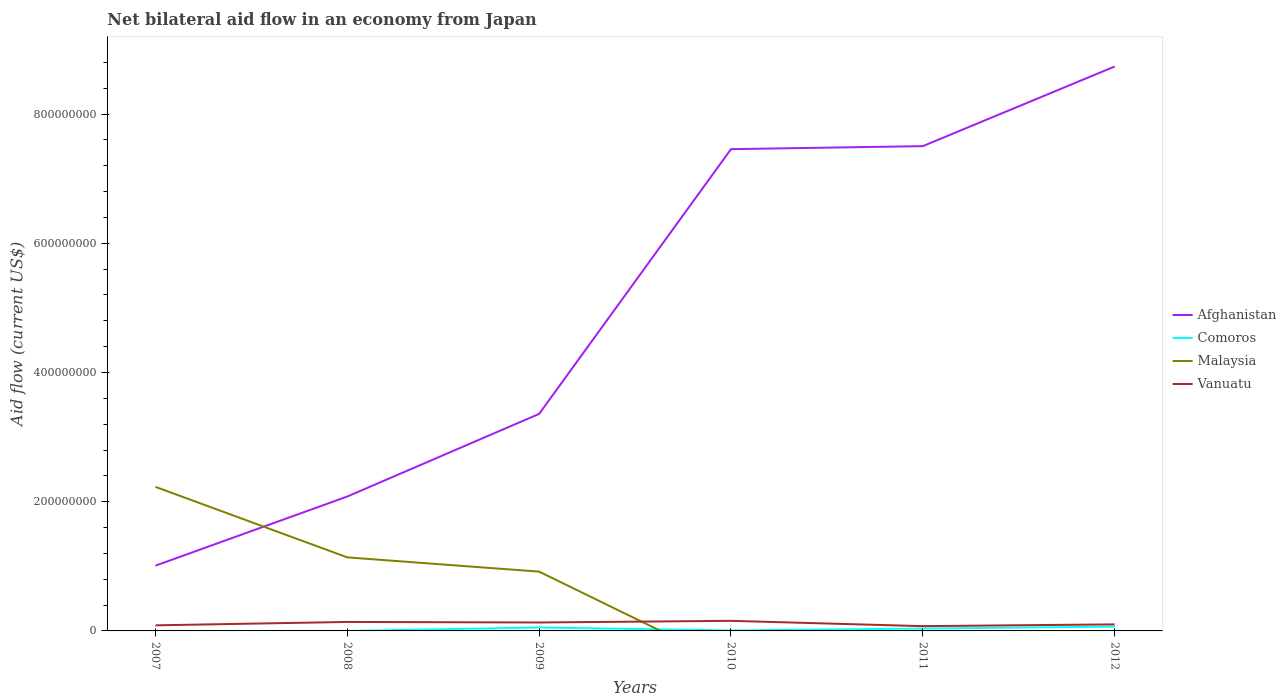What is the total net bilateral aid flow in Vanuatu in the graph?
Make the answer very short. -2.75e+06. What is the difference between the highest and the second highest net bilateral aid flow in Comoros?
Provide a succinct answer. 6.70e+06. Does the graph contain any zero values?
Your answer should be compact. Yes. How many legend labels are there?
Give a very brief answer. 4. How are the legend labels stacked?
Offer a very short reply. Vertical. What is the title of the graph?
Your answer should be very brief. Net bilateral aid flow in an economy from Japan. What is the label or title of the Y-axis?
Keep it short and to the point. Aid flow (current US$). What is the Aid flow (current US$) in Afghanistan in 2007?
Your response must be concise. 1.01e+08. What is the Aid flow (current US$) in Comoros in 2007?
Make the answer very short. 10000. What is the Aid flow (current US$) of Malaysia in 2007?
Offer a very short reply. 2.23e+08. What is the Aid flow (current US$) in Vanuatu in 2007?
Provide a succinct answer. 8.63e+06. What is the Aid flow (current US$) in Afghanistan in 2008?
Your answer should be very brief. 2.08e+08. What is the Aid flow (current US$) of Malaysia in 2008?
Offer a terse response. 1.14e+08. What is the Aid flow (current US$) in Vanuatu in 2008?
Keep it short and to the point. 1.39e+07. What is the Aid flow (current US$) in Afghanistan in 2009?
Your response must be concise. 3.36e+08. What is the Aid flow (current US$) in Comoros in 2009?
Give a very brief answer. 5.30e+06. What is the Aid flow (current US$) of Malaysia in 2009?
Keep it short and to the point. 9.18e+07. What is the Aid flow (current US$) in Vanuatu in 2009?
Make the answer very short. 1.31e+07. What is the Aid flow (current US$) in Afghanistan in 2010?
Your answer should be very brief. 7.46e+08. What is the Aid flow (current US$) of Comoros in 2010?
Offer a very short reply. 7.00e+05. What is the Aid flow (current US$) in Malaysia in 2010?
Offer a very short reply. 0. What is the Aid flow (current US$) in Vanuatu in 2010?
Ensure brevity in your answer.  1.56e+07. What is the Aid flow (current US$) of Afghanistan in 2011?
Provide a short and direct response. 7.50e+08. What is the Aid flow (current US$) in Comoros in 2011?
Offer a very short reply. 3.66e+06. What is the Aid flow (current US$) in Malaysia in 2011?
Make the answer very short. 0. What is the Aid flow (current US$) in Vanuatu in 2011?
Keep it short and to the point. 7.39e+06. What is the Aid flow (current US$) of Afghanistan in 2012?
Offer a terse response. 8.74e+08. What is the Aid flow (current US$) in Comoros in 2012?
Make the answer very short. 6.71e+06. What is the Aid flow (current US$) of Malaysia in 2012?
Offer a very short reply. 0. What is the Aid flow (current US$) of Vanuatu in 2012?
Provide a succinct answer. 1.01e+07. Across all years, what is the maximum Aid flow (current US$) in Afghanistan?
Your response must be concise. 8.74e+08. Across all years, what is the maximum Aid flow (current US$) in Comoros?
Offer a very short reply. 6.71e+06. Across all years, what is the maximum Aid flow (current US$) in Malaysia?
Provide a short and direct response. 2.23e+08. Across all years, what is the maximum Aid flow (current US$) of Vanuatu?
Ensure brevity in your answer.  1.56e+07. Across all years, what is the minimum Aid flow (current US$) in Afghanistan?
Ensure brevity in your answer.  1.01e+08. Across all years, what is the minimum Aid flow (current US$) in Malaysia?
Your answer should be compact. 0. Across all years, what is the minimum Aid flow (current US$) in Vanuatu?
Your answer should be very brief. 7.39e+06. What is the total Aid flow (current US$) in Afghanistan in the graph?
Provide a short and direct response. 3.01e+09. What is the total Aid flow (current US$) in Comoros in the graph?
Make the answer very short. 1.64e+07. What is the total Aid flow (current US$) in Malaysia in the graph?
Keep it short and to the point. 4.29e+08. What is the total Aid flow (current US$) in Vanuatu in the graph?
Offer a very short reply. 6.88e+07. What is the difference between the Aid flow (current US$) in Afghanistan in 2007 and that in 2008?
Provide a short and direct response. -1.07e+08. What is the difference between the Aid flow (current US$) in Comoros in 2007 and that in 2008?
Your response must be concise. -2.00e+04. What is the difference between the Aid flow (current US$) of Malaysia in 2007 and that in 2008?
Your answer should be very brief. 1.09e+08. What is the difference between the Aid flow (current US$) of Vanuatu in 2007 and that in 2008?
Offer a terse response. -5.28e+06. What is the difference between the Aid flow (current US$) of Afghanistan in 2007 and that in 2009?
Your response must be concise. -2.35e+08. What is the difference between the Aid flow (current US$) of Comoros in 2007 and that in 2009?
Your answer should be very brief. -5.29e+06. What is the difference between the Aid flow (current US$) of Malaysia in 2007 and that in 2009?
Ensure brevity in your answer.  1.31e+08. What is the difference between the Aid flow (current US$) of Vanuatu in 2007 and that in 2009?
Offer a very short reply. -4.44e+06. What is the difference between the Aid flow (current US$) of Afghanistan in 2007 and that in 2010?
Your response must be concise. -6.45e+08. What is the difference between the Aid flow (current US$) in Comoros in 2007 and that in 2010?
Offer a very short reply. -6.90e+05. What is the difference between the Aid flow (current US$) of Vanuatu in 2007 and that in 2010?
Provide a succinct answer. -6.98e+06. What is the difference between the Aid flow (current US$) in Afghanistan in 2007 and that in 2011?
Make the answer very short. -6.49e+08. What is the difference between the Aid flow (current US$) of Comoros in 2007 and that in 2011?
Ensure brevity in your answer.  -3.65e+06. What is the difference between the Aid flow (current US$) in Vanuatu in 2007 and that in 2011?
Your answer should be very brief. 1.24e+06. What is the difference between the Aid flow (current US$) in Afghanistan in 2007 and that in 2012?
Offer a very short reply. -7.73e+08. What is the difference between the Aid flow (current US$) of Comoros in 2007 and that in 2012?
Your answer should be very brief. -6.70e+06. What is the difference between the Aid flow (current US$) in Vanuatu in 2007 and that in 2012?
Provide a short and direct response. -1.51e+06. What is the difference between the Aid flow (current US$) of Afghanistan in 2008 and that in 2009?
Your answer should be very brief. -1.28e+08. What is the difference between the Aid flow (current US$) in Comoros in 2008 and that in 2009?
Your answer should be very brief. -5.27e+06. What is the difference between the Aid flow (current US$) of Malaysia in 2008 and that in 2009?
Your answer should be very brief. 2.20e+07. What is the difference between the Aid flow (current US$) of Vanuatu in 2008 and that in 2009?
Your response must be concise. 8.40e+05. What is the difference between the Aid flow (current US$) of Afghanistan in 2008 and that in 2010?
Offer a terse response. -5.38e+08. What is the difference between the Aid flow (current US$) in Comoros in 2008 and that in 2010?
Your response must be concise. -6.70e+05. What is the difference between the Aid flow (current US$) in Vanuatu in 2008 and that in 2010?
Provide a succinct answer. -1.70e+06. What is the difference between the Aid flow (current US$) of Afghanistan in 2008 and that in 2011?
Your response must be concise. -5.42e+08. What is the difference between the Aid flow (current US$) in Comoros in 2008 and that in 2011?
Your answer should be compact. -3.63e+06. What is the difference between the Aid flow (current US$) in Vanuatu in 2008 and that in 2011?
Offer a terse response. 6.52e+06. What is the difference between the Aid flow (current US$) in Afghanistan in 2008 and that in 2012?
Give a very brief answer. -6.66e+08. What is the difference between the Aid flow (current US$) in Comoros in 2008 and that in 2012?
Make the answer very short. -6.68e+06. What is the difference between the Aid flow (current US$) of Vanuatu in 2008 and that in 2012?
Keep it short and to the point. 3.77e+06. What is the difference between the Aid flow (current US$) of Afghanistan in 2009 and that in 2010?
Your response must be concise. -4.10e+08. What is the difference between the Aid flow (current US$) in Comoros in 2009 and that in 2010?
Ensure brevity in your answer.  4.60e+06. What is the difference between the Aid flow (current US$) in Vanuatu in 2009 and that in 2010?
Your answer should be compact. -2.54e+06. What is the difference between the Aid flow (current US$) in Afghanistan in 2009 and that in 2011?
Give a very brief answer. -4.14e+08. What is the difference between the Aid flow (current US$) of Comoros in 2009 and that in 2011?
Keep it short and to the point. 1.64e+06. What is the difference between the Aid flow (current US$) of Vanuatu in 2009 and that in 2011?
Provide a short and direct response. 5.68e+06. What is the difference between the Aid flow (current US$) in Afghanistan in 2009 and that in 2012?
Offer a terse response. -5.38e+08. What is the difference between the Aid flow (current US$) of Comoros in 2009 and that in 2012?
Your answer should be compact. -1.41e+06. What is the difference between the Aid flow (current US$) in Vanuatu in 2009 and that in 2012?
Make the answer very short. 2.93e+06. What is the difference between the Aid flow (current US$) in Afghanistan in 2010 and that in 2011?
Your answer should be compact. -4.68e+06. What is the difference between the Aid flow (current US$) in Comoros in 2010 and that in 2011?
Make the answer very short. -2.96e+06. What is the difference between the Aid flow (current US$) in Vanuatu in 2010 and that in 2011?
Offer a terse response. 8.22e+06. What is the difference between the Aid flow (current US$) of Afghanistan in 2010 and that in 2012?
Give a very brief answer. -1.28e+08. What is the difference between the Aid flow (current US$) of Comoros in 2010 and that in 2012?
Make the answer very short. -6.01e+06. What is the difference between the Aid flow (current US$) in Vanuatu in 2010 and that in 2012?
Ensure brevity in your answer.  5.47e+06. What is the difference between the Aid flow (current US$) in Afghanistan in 2011 and that in 2012?
Ensure brevity in your answer.  -1.23e+08. What is the difference between the Aid flow (current US$) in Comoros in 2011 and that in 2012?
Make the answer very short. -3.05e+06. What is the difference between the Aid flow (current US$) of Vanuatu in 2011 and that in 2012?
Your answer should be compact. -2.75e+06. What is the difference between the Aid flow (current US$) of Afghanistan in 2007 and the Aid flow (current US$) of Comoros in 2008?
Ensure brevity in your answer.  1.01e+08. What is the difference between the Aid flow (current US$) of Afghanistan in 2007 and the Aid flow (current US$) of Malaysia in 2008?
Your answer should be compact. -1.28e+07. What is the difference between the Aid flow (current US$) in Afghanistan in 2007 and the Aid flow (current US$) in Vanuatu in 2008?
Ensure brevity in your answer.  8.71e+07. What is the difference between the Aid flow (current US$) in Comoros in 2007 and the Aid flow (current US$) in Malaysia in 2008?
Give a very brief answer. -1.14e+08. What is the difference between the Aid flow (current US$) in Comoros in 2007 and the Aid flow (current US$) in Vanuatu in 2008?
Your answer should be compact. -1.39e+07. What is the difference between the Aid flow (current US$) in Malaysia in 2007 and the Aid flow (current US$) in Vanuatu in 2008?
Your answer should be very brief. 2.09e+08. What is the difference between the Aid flow (current US$) in Afghanistan in 2007 and the Aid flow (current US$) in Comoros in 2009?
Ensure brevity in your answer.  9.57e+07. What is the difference between the Aid flow (current US$) in Afghanistan in 2007 and the Aid flow (current US$) in Malaysia in 2009?
Your response must be concise. 9.23e+06. What is the difference between the Aid flow (current US$) in Afghanistan in 2007 and the Aid flow (current US$) in Vanuatu in 2009?
Offer a terse response. 8.79e+07. What is the difference between the Aid flow (current US$) of Comoros in 2007 and the Aid flow (current US$) of Malaysia in 2009?
Offer a terse response. -9.18e+07. What is the difference between the Aid flow (current US$) in Comoros in 2007 and the Aid flow (current US$) in Vanuatu in 2009?
Make the answer very short. -1.31e+07. What is the difference between the Aid flow (current US$) of Malaysia in 2007 and the Aid flow (current US$) of Vanuatu in 2009?
Your response must be concise. 2.10e+08. What is the difference between the Aid flow (current US$) of Afghanistan in 2007 and the Aid flow (current US$) of Comoros in 2010?
Offer a very short reply. 1.00e+08. What is the difference between the Aid flow (current US$) in Afghanistan in 2007 and the Aid flow (current US$) in Vanuatu in 2010?
Your response must be concise. 8.54e+07. What is the difference between the Aid flow (current US$) in Comoros in 2007 and the Aid flow (current US$) in Vanuatu in 2010?
Your answer should be very brief. -1.56e+07. What is the difference between the Aid flow (current US$) of Malaysia in 2007 and the Aid flow (current US$) of Vanuatu in 2010?
Provide a succinct answer. 2.07e+08. What is the difference between the Aid flow (current US$) in Afghanistan in 2007 and the Aid flow (current US$) in Comoros in 2011?
Your answer should be compact. 9.74e+07. What is the difference between the Aid flow (current US$) in Afghanistan in 2007 and the Aid flow (current US$) in Vanuatu in 2011?
Offer a terse response. 9.36e+07. What is the difference between the Aid flow (current US$) of Comoros in 2007 and the Aid flow (current US$) of Vanuatu in 2011?
Ensure brevity in your answer.  -7.38e+06. What is the difference between the Aid flow (current US$) in Malaysia in 2007 and the Aid flow (current US$) in Vanuatu in 2011?
Your response must be concise. 2.16e+08. What is the difference between the Aid flow (current US$) in Afghanistan in 2007 and the Aid flow (current US$) in Comoros in 2012?
Offer a very short reply. 9.43e+07. What is the difference between the Aid flow (current US$) of Afghanistan in 2007 and the Aid flow (current US$) of Vanuatu in 2012?
Give a very brief answer. 9.09e+07. What is the difference between the Aid flow (current US$) of Comoros in 2007 and the Aid flow (current US$) of Vanuatu in 2012?
Provide a short and direct response. -1.01e+07. What is the difference between the Aid flow (current US$) of Malaysia in 2007 and the Aid flow (current US$) of Vanuatu in 2012?
Ensure brevity in your answer.  2.13e+08. What is the difference between the Aid flow (current US$) of Afghanistan in 2008 and the Aid flow (current US$) of Comoros in 2009?
Offer a terse response. 2.03e+08. What is the difference between the Aid flow (current US$) in Afghanistan in 2008 and the Aid flow (current US$) in Malaysia in 2009?
Your answer should be very brief. 1.16e+08. What is the difference between the Aid flow (current US$) in Afghanistan in 2008 and the Aid flow (current US$) in Vanuatu in 2009?
Offer a terse response. 1.95e+08. What is the difference between the Aid flow (current US$) of Comoros in 2008 and the Aid flow (current US$) of Malaysia in 2009?
Provide a succinct answer. -9.18e+07. What is the difference between the Aid flow (current US$) of Comoros in 2008 and the Aid flow (current US$) of Vanuatu in 2009?
Provide a short and direct response. -1.30e+07. What is the difference between the Aid flow (current US$) of Malaysia in 2008 and the Aid flow (current US$) of Vanuatu in 2009?
Provide a short and direct response. 1.01e+08. What is the difference between the Aid flow (current US$) of Afghanistan in 2008 and the Aid flow (current US$) of Comoros in 2010?
Ensure brevity in your answer.  2.07e+08. What is the difference between the Aid flow (current US$) of Afghanistan in 2008 and the Aid flow (current US$) of Vanuatu in 2010?
Your answer should be compact. 1.92e+08. What is the difference between the Aid flow (current US$) of Comoros in 2008 and the Aid flow (current US$) of Vanuatu in 2010?
Ensure brevity in your answer.  -1.56e+07. What is the difference between the Aid flow (current US$) of Malaysia in 2008 and the Aid flow (current US$) of Vanuatu in 2010?
Your answer should be very brief. 9.82e+07. What is the difference between the Aid flow (current US$) in Afghanistan in 2008 and the Aid flow (current US$) in Comoros in 2011?
Give a very brief answer. 2.04e+08. What is the difference between the Aid flow (current US$) of Afghanistan in 2008 and the Aid flow (current US$) of Vanuatu in 2011?
Your answer should be compact. 2.01e+08. What is the difference between the Aid flow (current US$) of Comoros in 2008 and the Aid flow (current US$) of Vanuatu in 2011?
Make the answer very short. -7.36e+06. What is the difference between the Aid flow (current US$) of Malaysia in 2008 and the Aid flow (current US$) of Vanuatu in 2011?
Your answer should be compact. 1.06e+08. What is the difference between the Aid flow (current US$) of Afghanistan in 2008 and the Aid flow (current US$) of Comoros in 2012?
Make the answer very short. 2.01e+08. What is the difference between the Aid flow (current US$) of Afghanistan in 2008 and the Aid flow (current US$) of Vanuatu in 2012?
Provide a short and direct response. 1.98e+08. What is the difference between the Aid flow (current US$) in Comoros in 2008 and the Aid flow (current US$) in Vanuatu in 2012?
Give a very brief answer. -1.01e+07. What is the difference between the Aid flow (current US$) in Malaysia in 2008 and the Aid flow (current US$) in Vanuatu in 2012?
Ensure brevity in your answer.  1.04e+08. What is the difference between the Aid flow (current US$) of Afghanistan in 2009 and the Aid flow (current US$) of Comoros in 2010?
Your answer should be very brief. 3.35e+08. What is the difference between the Aid flow (current US$) of Afghanistan in 2009 and the Aid flow (current US$) of Vanuatu in 2010?
Your answer should be compact. 3.20e+08. What is the difference between the Aid flow (current US$) in Comoros in 2009 and the Aid flow (current US$) in Vanuatu in 2010?
Make the answer very short. -1.03e+07. What is the difference between the Aid flow (current US$) in Malaysia in 2009 and the Aid flow (current US$) in Vanuatu in 2010?
Keep it short and to the point. 7.62e+07. What is the difference between the Aid flow (current US$) of Afghanistan in 2009 and the Aid flow (current US$) of Comoros in 2011?
Offer a terse response. 3.32e+08. What is the difference between the Aid flow (current US$) of Afghanistan in 2009 and the Aid flow (current US$) of Vanuatu in 2011?
Ensure brevity in your answer.  3.29e+08. What is the difference between the Aid flow (current US$) of Comoros in 2009 and the Aid flow (current US$) of Vanuatu in 2011?
Offer a very short reply. -2.09e+06. What is the difference between the Aid flow (current US$) in Malaysia in 2009 and the Aid flow (current US$) in Vanuatu in 2011?
Offer a very short reply. 8.44e+07. What is the difference between the Aid flow (current US$) of Afghanistan in 2009 and the Aid flow (current US$) of Comoros in 2012?
Your response must be concise. 3.29e+08. What is the difference between the Aid flow (current US$) in Afghanistan in 2009 and the Aid flow (current US$) in Vanuatu in 2012?
Provide a short and direct response. 3.26e+08. What is the difference between the Aid flow (current US$) of Comoros in 2009 and the Aid flow (current US$) of Vanuatu in 2012?
Your answer should be compact. -4.84e+06. What is the difference between the Aid flow (current US$) of Malaysia in 2009 and the Aid flow (current US$) of Vanuatu in 2012?
Ensure brevity in your answer.  8.16e+07. What is the difference between the Aid flow (current US$) of Afghanistan in 2010 and the Aid flow (current US$) of Comoros in 2011?
Your answer should be very brief. 7.42e+08. What is the difference between the Aid flow (current US$) in Afghanistan in 2010 and the Aid flow (current US$) in Vanuatu in 2011?
Offer a terse response. 7.38e+08. What is the difference between the Aid flow (current US$) of Comoros in 2010 and the Aid flow (current US$) of Vanuatu in 2011?
Your response must be concise. -6.69e+06. What is the difference between the Aid flow (current US$) in Afghanistan in 2010 and the Aid flow (current US$) in Comoros in 2012?
Offer a terse response. 7.39e+08. What is the difference between the Aid flow (current US$) in Afghanistan in 2010 and the Aid flow (current US$) in Vanuatu in 2012?
Your answer should be compact. 7.36e+08. What is the difference between the Aid flow (current US$) of Comoros in 2010 and the Aid flow (current US$) of Vanuatu in 2012?
Provide a succinct answer. -9.44e+06. What is the difference between the Aid flow (current US$) of Afghanistan in 2011 and the Aid flow (current US$) of Comoros in 2012?
Keep it short and to the point. 7.44e+08. What is the difference between the Aid flow (current US$) of Afghanistan in 2011 and the Aid flow (current US$) of Vanuatu in 2012?
Offer a very short reply. 7.40e+08. What is the difference between the Aid flow (current US$) in Comoros in 2011 and the Aid flow (current US$) in Vanuatu in 2012?
Your answer should be compact. -6.48e+06. What is the average Aid flow (current US$) in Afghanistan per year?
Offer a terse response. 5.02e+08. What is the average Aid flow (current US$) in Comoros per year?
Your response must be concise. 2.74e+06. What is the average Aid flow (current US$) in Malaysia per year?
Give a very brief answer. 7.14e+07. What is the average Aid flow (current US$) of Vanuatu per year?
Offer a very short reply. 1.15e+07. In the year 2007, what is the difference between the Aid flow (current US$) in Afghanistan and Aid flow (current US$) in Comoros?
Keep it short and to the point. 1.01e+08. In the year 2007, what is the difference between the Aid flow (current US$) in Afghanistan and Aid flow (current US$) in Malaysia?
Offer a very short reply. -1.22e+08. In the year 2007, what is the difference between the Aid flow (current US$) in Afghanistan and Aid flow (current US$) in Vanuatu?
Give a very brief answer. 9.24e+07. In the year 2007, what is the difference between the Aid flow (current US$) in Comoros and Aid flow (current US$) in Malaysia?
Your answer should be compact. -2.23e+08. In the year 2007, what is the difference between the Aid flow (current US$) of Comoros and Aid flow (current US$) of Vanuatu?
Offer a very short reply. -8.62e+06. In the year 2007, what is the difference between the Aid flow (current US$) in Malaysia and Aid flow (current US$) in Vanuatu?
Offer a terse response. 2.14e+08. In the year 2008, what is the difference between the Aid flow (current US$) of Afghanistan and Aid flow (current US$) of Comoros?
Your answer should be compact. 2.08e+08. In the year 2008, what is the difference between the Aid flow (current US$) in Afghanistan and Aid flow (current US$) in Malaysia?
Ensure brevity in your answer.  9.42e+07. In the year 2008, what is the difference between the Aid flow (current US$) in Afghanistan and Aid flow (current US$) in Vanuatu?
Give a very brief answer. 1.94e+08. In the year 2008, what is the difference between the Aid flow (current US$) in Comoros and Aid flow (current US$) in Malaysia?
Your answer should be very brief. -1.14e+08. In the year 2008, what is the difference between the Aid flow (current US$) in Comoros and Aid flow (current US$) in Vanuatu?
Your response must be concise. -1.39e+07. In the year 2008, what is the difference between the Aid flow (current US$) of Malaysia and Aid flow (current US$) of Vanuatu?
Your answer should be compact. 9.99e+07. In the year 2009, what is the difference between the Aid flow (current US$) in Afghanistan and Aid flow (current US$) in Comoros?
Offer a very short reply. 3.31e+08. In the year 2009, what is the difference between the Aid flow (current US$) of Afghanistan and Aid flow (current US$) of Malaysia?
Your response must be concise. 2.44e+08. In the year 2009, what is the difference between the Aid flow (current US$) of Afghanistan and Aid flow (current US$) of Vanuatu?
Offer a very short reply. 3.23e+08. In the year 2009, what is the difference between the Aid flow (current US$) in Comoros and Aid flow (current US$) in Malaysia?
Make the answer very short. -8.65e+07. In the year 2009, what is the difference between the Aid flow (current US$) in Comoros and Aid flow (current US$) in Vanuatu?
Keep it short and to the point. -7.77e+06. In the year 2009, what is the difference between the Aid flow (current US$) of Malaysia and Aid flow (current US$) of Vanuatu?
Offer a terse response. 7.87e+07. In the year 2010, what is the difference between the Aid flow (current US$) in Afghanistan and Aid flow (current US$) in Comoros?
Ensure brevity in your answer.  7.45e+08. In the year 2010, what is the difference between the Aid flow (current US$) of Afghanistan and Aid flow (current US$) of Vanuatu?
Keep it short and to the point. 7.30e+08. In the year 2010, what is the difference between the Aid flow (current US$) of Comoros and Aid flow (current US$) of Vanuatu?
Ensure brevity in your answer.  -1.49e+07. In the year 2011, what is the difference between the Aid flow (current US$) of Afghanistan and Aid flow (current US$) of Comoros?
Make the answer very short. 7.47e+08. In the year 2011, what is the difference between the Aid flow (current US$) in Afghanistan and Aid flow (current US$) in Vanuatu?
Offer a very short reply. 7.43e+08. In the year 2011, what is the difference between the Aid flow (current US$) of Comoros and Aid flow (current US$) of Vanuatu?
Make the answer very short. -3.73e+06. In the year 2012, what is the difference between the Aid flow (current US$) in Afghanistan and Aid flow (current US$) in Comoros?
Your answer should be compact. 8.67e+08. In the year 2012, what is the difference between the Aid flow (current US$) in Afghanistan and Aid flow (current US$) in Vanuatu?
Your answer should be compact. 8.63e+08. In the year 2012, what is the difference between the Aid flow (current US$) in Comoros and Aid flow (current US$) in Vanuatu?
Make the answer very short. -3.43e+06. What is the ratio of the Aid flow (current US$) in Afghanistan in 2007 to that in 2008?
Offer a very short reply. 0.49. What is the ratio of the Aid flow (current US$) in Malaysia in 2007 to that in 2008?
Provide a short and direct response. 1.96. What is the ratio of the Aid flow (current US$) in Vanuatu in 2007 to that in 2008?
Keep it short and to the point. 0.62. What is the ratio of the Aid flow (current US$) of Afghanistan in 2007 to that in 2009?
Offer a very short reply. 0.3. What is the ratio of the Aid flow (current US$) in Comoros in 2007 to that in 2009?
Your answer should be very brief. 0. What is the ratio of the Aid flow (current US$) in Malaysia in 2007 to that in 2009?
Your response must be concise. 2.43. What is the ratio of the Aid flow (current US$) of Vanuatu in 2007 to that in 2009?
Your response must be concise. 0.66. What is the ratio of the Aid flow (current US$) of Afghanistan in 2007 to that in 2010?
Provide a short and direct response. 0.14. What is the ratio of the Aid flow (current US$) of Comoros in 2007 to that in 2010?
Provide a short and direct response. 0.01. What is the ratio of the Aid flow (current US$) in Vanuatu in 2007 to that in 2010?
Offer a terse response. 0.55. What is the ratio of the Aid flow (current US$) in Afghanistan in 2007 to that in 2011?
Offer a very short reply. 0.13. What is the ratio of the Aid flow (current US$) of Comoros in 2007 to that in 2011?
Ensure brevity in your answer.  0. What is the ratio of the Aid flow (current US$) in Vanuatu in 2007 to that in 2011?
Give a very brief answer. 1.17. What is the ratio of the Aid flow (current US$) of Afghanistan in 2007 to that in 2012?
Provide a short and direct response. 0.12. What is the ratio of the Aid flow (current US$) in Comoros in 2007 to that in 2012?
Your answer should be compact. 0. What is the ratio of the Aid flow (current US$) in Vanuatu in 2007 to that in 2012?
Offer a very short reply. 0.85. What is the ratio of the Aid flow (current US$) in Afghanistan in 2008 to that in 2009?
Your answer should be compact. 0.62. What is the ratio of the Aid flow (current US$) of Comoros in 2008 to that in 2009?
Your answer should be compact. 0.01. What is the ratio of the Aid flow (current US$) of Malaysia in 2008 to that in 2009?
Your answer should be very brief. 1.24. What is the ratio of the Aid flow (current US$) of Vanuatu in 2008 to that in 2009?
Ensure brevity in your answer.  1.06. What is the ratio of the Aid flow (current US$) in Afghanistan in 2008 to that in 2010?
Provide a short and direct response. 0.28. What is the ratio of the Aid flow (current US$) of Comoros in 2008 to that in 2010?
Your answer should be very brief. 0.04. What is the ratio of the Aid flow (current US$) of Vanuatu in 2008 to that in 2010?
Offer a terse response. 0.89. What is the ratio of the Aid flow (current US$) in Afghanistan in 2008 to that in 2011?
Your answer should be compact. 0.28. What is the ratio of the Aid flow (current US$) of Comoros in 2008 to that in 2011?
Provide a succinct answer. 0.01. What is the ratio of the Aid flow (current US$) of Vanuatu in 2008 to that in 2011?
Make the answer very short. 1.88. What is the ratio of the Aid flow (current US$) of Afghanistan in 2008 to that in 2012?
Give a very brief answer. 0.24. What is the ratio of the Aid flow (current US$) in Comoros in 2008 to that in 2012?
Provide a succinct answer. 0. What is the ratio of the Aid flow (current US$) in Vanuatu in 2008 to that in 2012?
Offer a very short reply. 1.37. What is the ratio of the Aid flow (current US$) of Afghanistan in 2009 to that in 2010?
Your answer should be compact. 0.45. What is the ratio of the Aid flow (current US$) in Comoros in 2009 to that in 2010?
Offer a terse response. 7.57. What is the ratio of the Aid flow (current US$) of Vanuatu in 2009 to that in 2010?
Provide a short and direct response. 0.84. What is the ratio of the Aid flow (current US$) in Afghanistan in 2009 to that in 2011?
Your answer should be compact. 0.45. What is the ratio of the Aid flow (current US$) in Comoros in 2009 to that in 2011?
Give a very brief answer. 1.45. What is the ratio of the Aid flow (current US$) of Vanuatu in 2009 to that in 2011?
Offer a terse response. 1.77. What is the ratio of the Aid flow (current US$) in Afghanistan in 2009 to that in 2012?
Offer a very short reply. 0.38. What is the ratio of the Aid flow (current US$) in Comoros in 2009 to that in 2012?
Keep it short and to the point. 0.79. What is the ratio of the Aid flow (current US$) of Vanuatu in 2009 to that in 2012?
Your answer should be very brief. 1.29. What is the ratio of the Aid flow (current US$) of Comoros in 2010 to that in 2011?
Your response must be concise. 0.19. What is the ratio of the Aid flow (current US$) in Vanuatu in 2010 to that in 2011?
Give a very brief answer. 2.11. What is the ratio of the Aid flow (current US$) in Afghanistan in 2010 to that in 2012?
Your response must be concise. 0.85. What is the ratio of the Aid flow (current US$) of Comoros in 2010 to that in 2012?
Your answer should be compact. 0.1. What is the ratio of the Aid flow (current US$) of Vanuatu in 2010 to that in 2012?
Your response must be concise. 1.54. What is the ratio of the Aid flow (current US$) in Afghanistan in 2011 to that in 2012?
Offer a very short reply. 0.86. What is the ratio of the Aid flow (current US$) in Comoros in 2011 to that in 2012?
Make the answer very short. 0.55. What is the ratio of the Aid flow (current US$) of Vanuatu in 2011 to that in 2012?
Your answer should be very brief. 0.73. What is the difference between the highest and the second highest Aid flow (current US$) of Afghanistan?
Provide a succinct answer. 1.23e+08. What is the difference between the highest and the second highest Aid flow (current US$) of Comoros?
Your response must be concise. 1.41e+06. What is the difference between the highest and the second highest Aid flow (current US$) of Malaysia?
Provide a short and direct response. 1.09e+08. What is the difference between the highest and the second highest Aid flow (current US$) of Vanuatu?
Provide a short and direct response. 1.70e+06. What is the difference between the highest and the lowest Aid flow (current US$) of Afghanistan?
Offer a terse response. 7.73e+08. What is the difference between the highest and the lowest Aid flow (current US$) of Comoros?
Provide a succinct answer. 6.70e+06. What is the difference between the highest and the lowest Aid flow (current US$) of Malaysia?
Your response must be concise. 2.23e+08. What is the difference between the highest and the lowest Aid flow (current US$) in Vanuatu?
Your answer should be compact. 8.22e+06. 